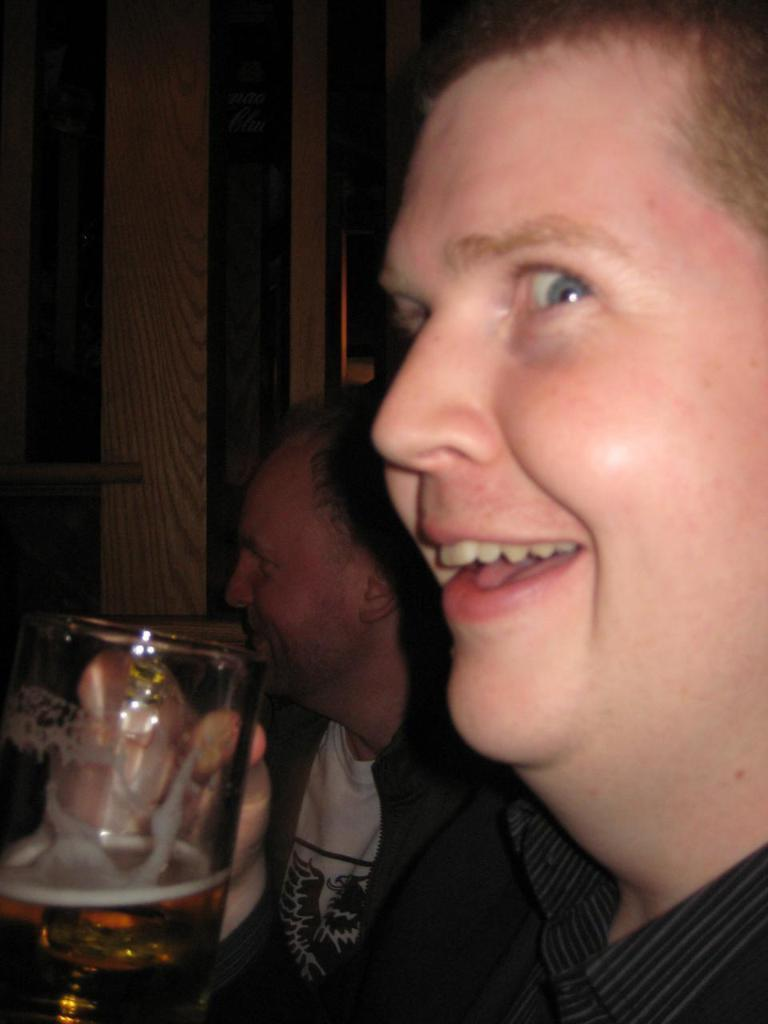What is the main subject of the image? There is a man in the image. What is the man doing in the image? The man is smiling and holding a wine glass. Are there any other people in the image? Yes, there is another man in the image. What is the second man doing in the image? The second man is sitting. What type of art can be seen hanging on the wall in the image? There is no art or wall visible in the image; it only features two men, one standing and smiling while holding a wine glass, and the other sitting. How many rabbits are present in the image? There are no rabbits present in the image. 